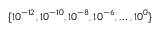<formula> <loc_0><loc_0><loc_500><loc_500>\{ 1 0 ^ { - 1 2 } , 1 0 ^ { - 1 0 } , 1 0 ^ { - 8 } , 1 0 ^ { - 6 } , \dots , 1 0 ^ { 0 } \}</formula> 